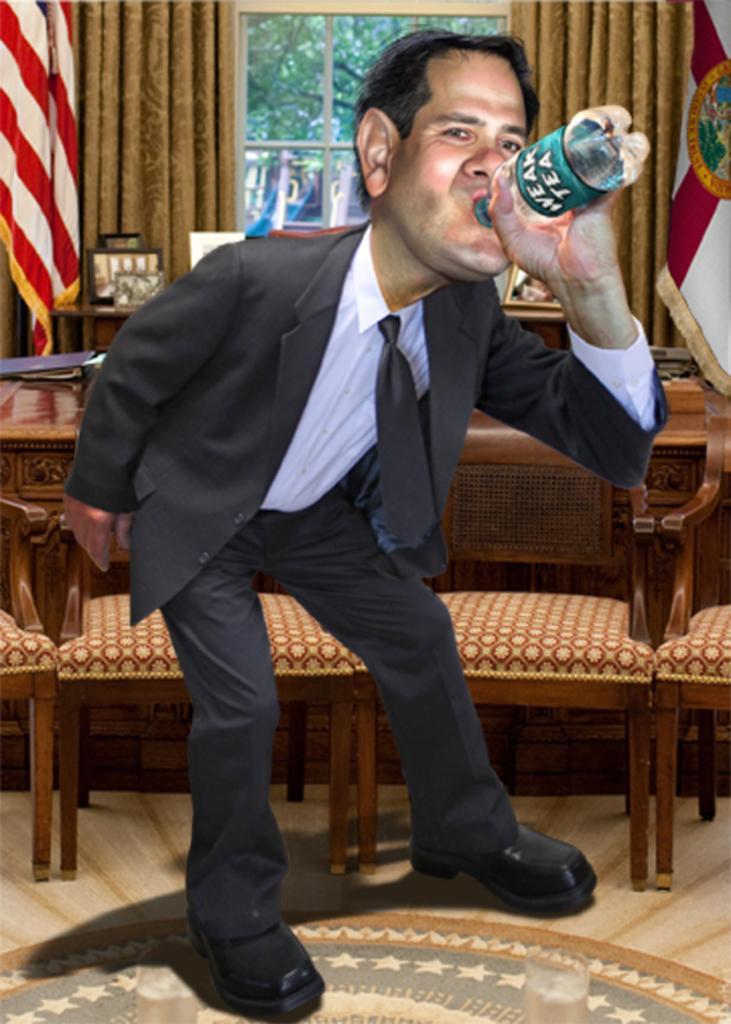Please provide a concise description of this image. This picture is an edited image. In the center, there is a person in black blazer, black trousers and he is holding a bottle. Behind him there are chairs and tables. On the top there are curtains and flags on either side of the image. Through the window, we can see the trees. 